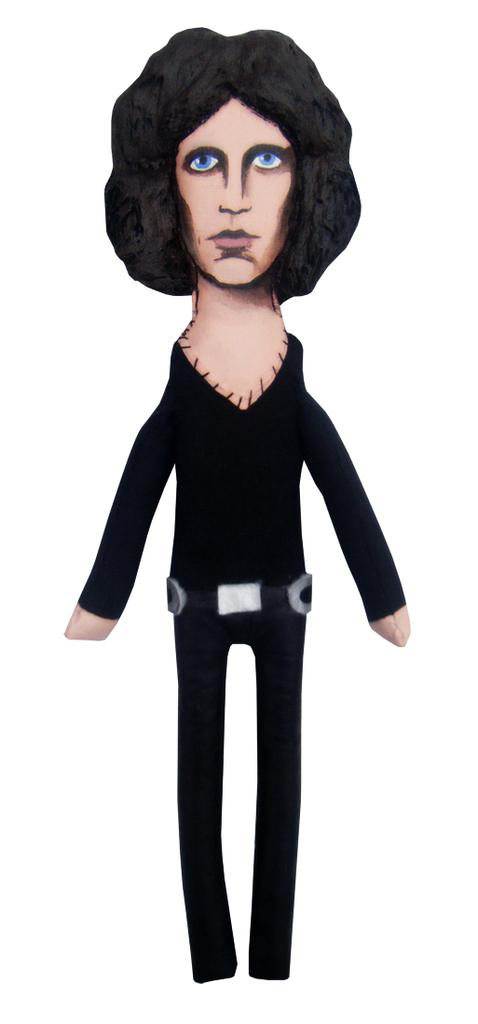What is the main subject of the picture? The main subject of the picture is a man. What is the man doing in the picture? The man is standing in the picture. What color is the man's shirt? The man is wearing a black shirt. What color are the man's pants? The man is wearing black pants. What is the background of the picture? There is a white backdrop in the picture. What type of powder is the man using to make pies in the image? There is no powder or pies present in the image; it features a man standing against a white backdrop. 